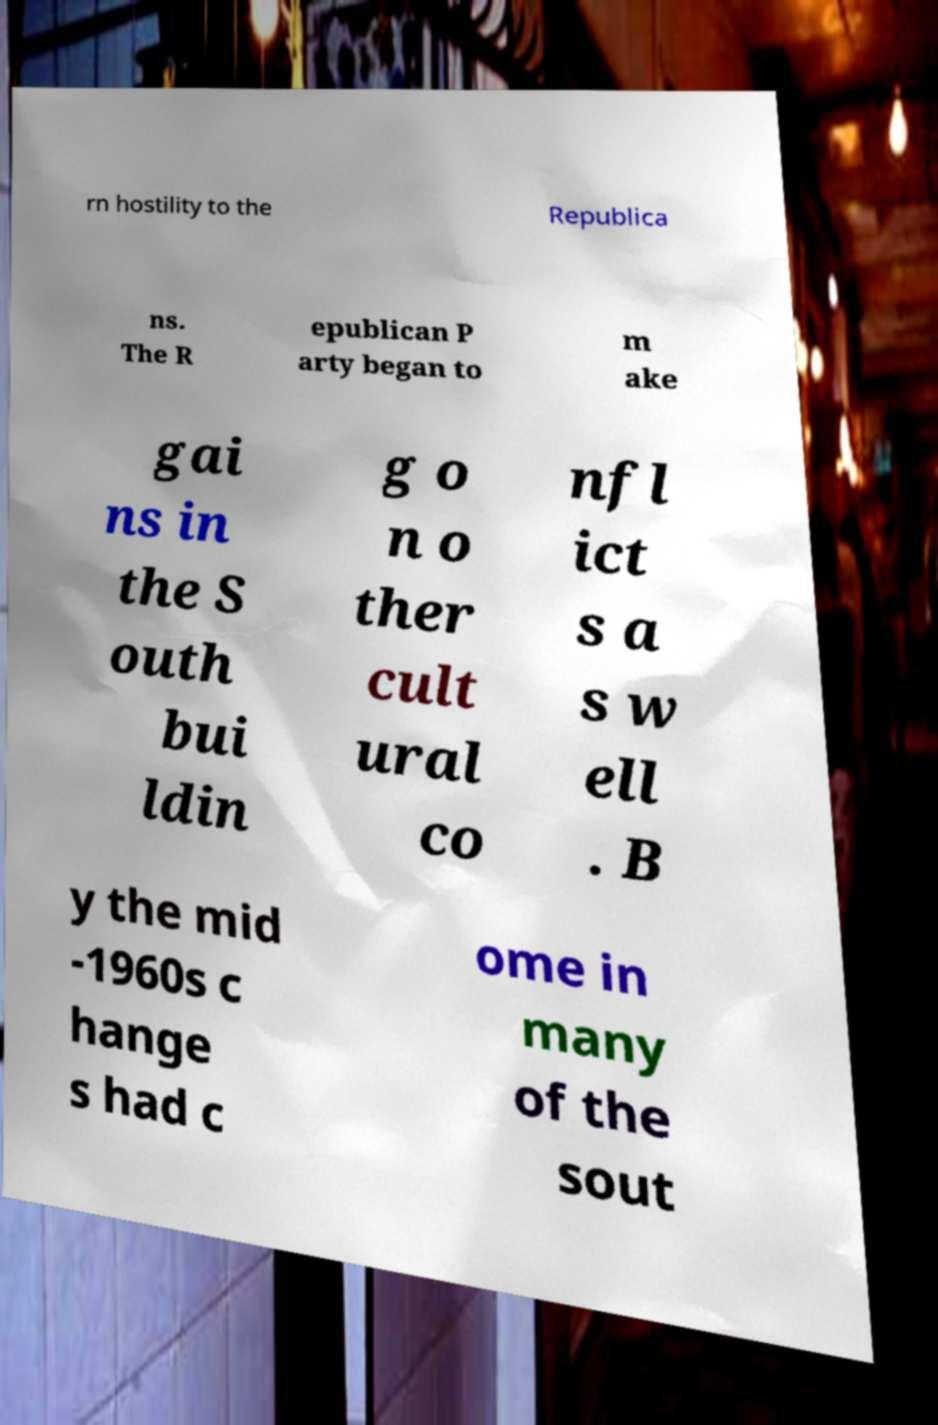Please identify and transcribe the text found in this image. rn hostility to the Republica ns. The R epublican P arty began to m ake gai ns in the S outh bui ldin g o n o ther cult ural co nfl ict s a s w ell . B y the mid -1960s c hange s had c ome in many of the sout 